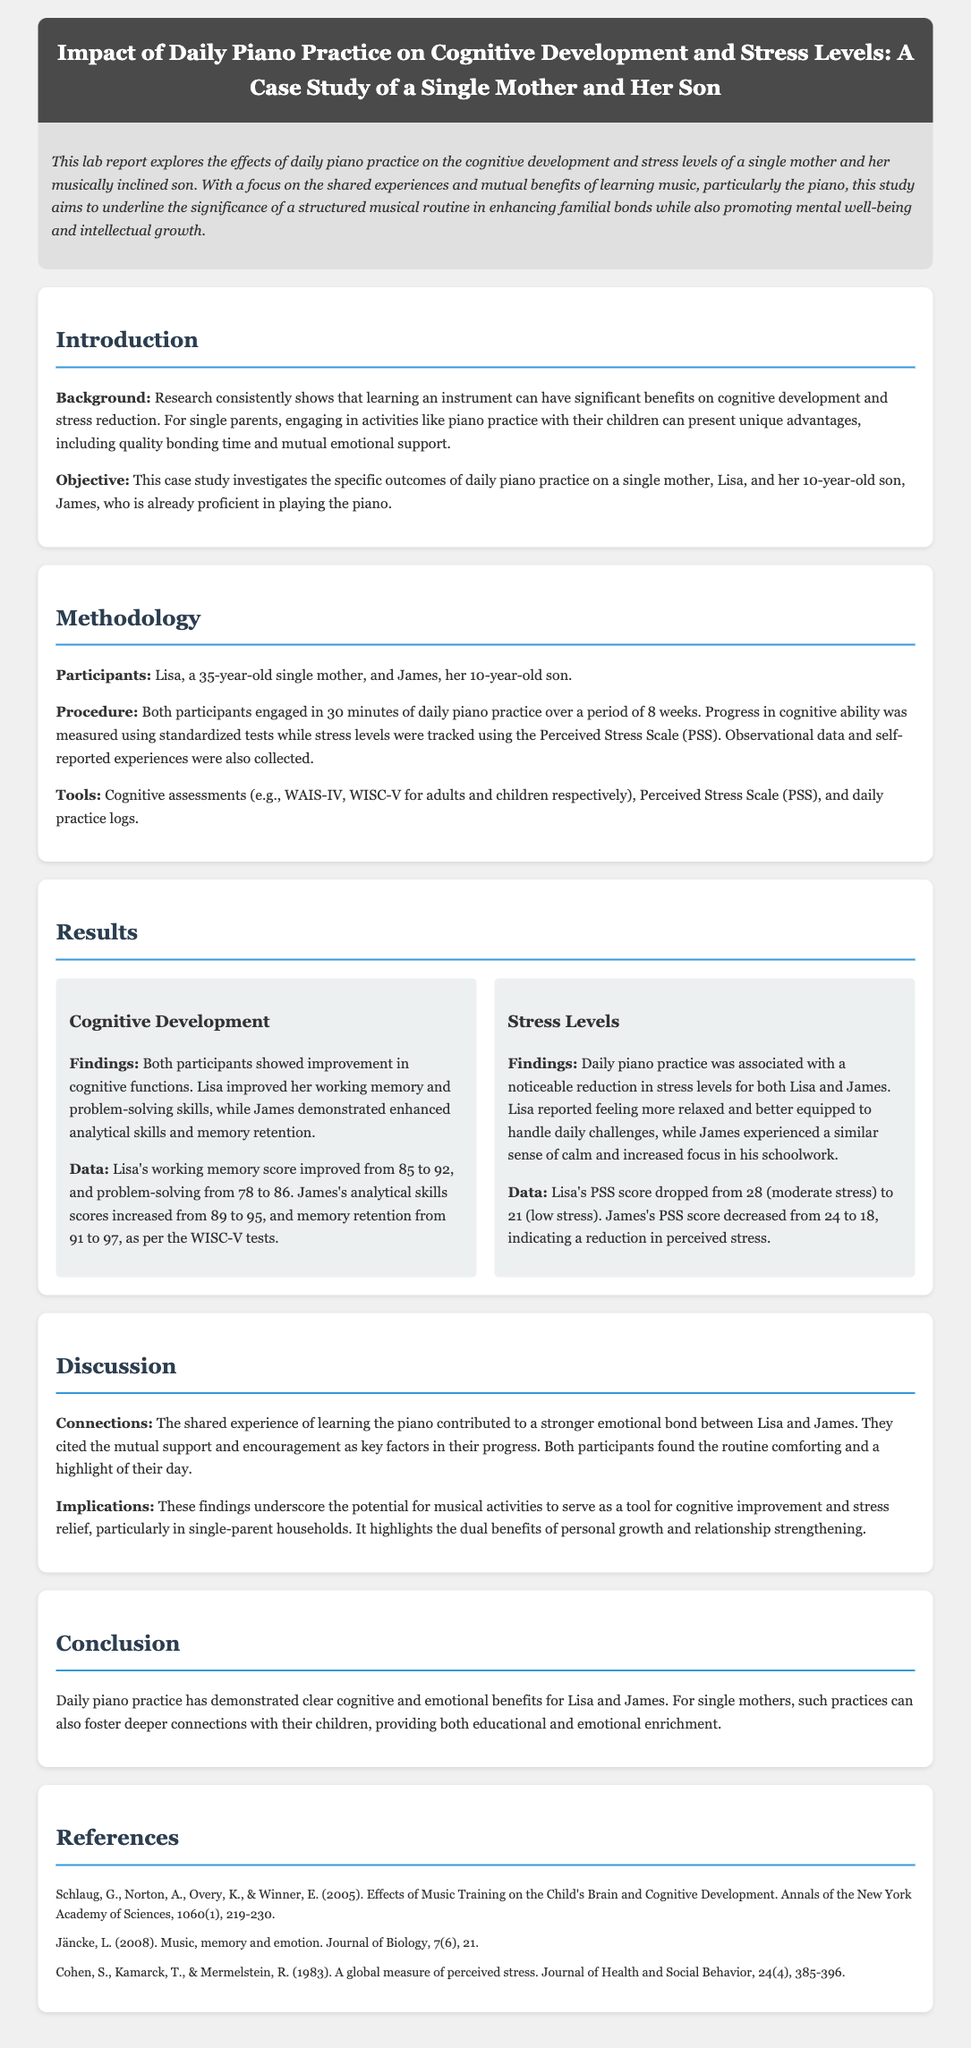what is the title of the lab report? The title of the lab report is provided in the header section, reflecting the focus of the research.
Answer: Impact of Daily Piano Practice on Cognitive Development and Stress Levels: A Case Study of a Single Mother and Her Son who are the participants in the study? The study identifies the participants as a single mother named Lisa and her son named James.
Answer: Lisa and James how long was the daily piano practice conducted? The duration of the daily piano practice is stated in the methodologies section.
Answer: 8 weeks what tool was used to measure stress levels? The document specifies the use of the Perceived Stress Scale (PSS) for tracking stress levels.
Answer: Perceived Stress Scale (PSS) what was the improvement in Lisa's working memory score? The results provide specific score changes for cognitive assessments, focusing on Lisa's performance.
Answer: from 85 to 92 what was the initial PSS score for James? The initial PSS score for James is mentioned in the results section, indicating his stress level before the practice.
Answer: 24 what key factor contributed to the emotional bond between Lisa and James? The discussion highlights the shared experience of learning piano as a significant contributor to their emotional bond.
Answer: mutual support and encouragement what was the objective of the case study? The objective of the case study is clearly stated in the introduction, detailing the focus of the research.
Answer: Investigates the specific outcomes of daily piano practice how were cognitive abilities measured in the study? The methodology outlines the cognitive assessments used for evaluation, specifying the tests involved.
Answer: WAIS-IV, WISC-V 